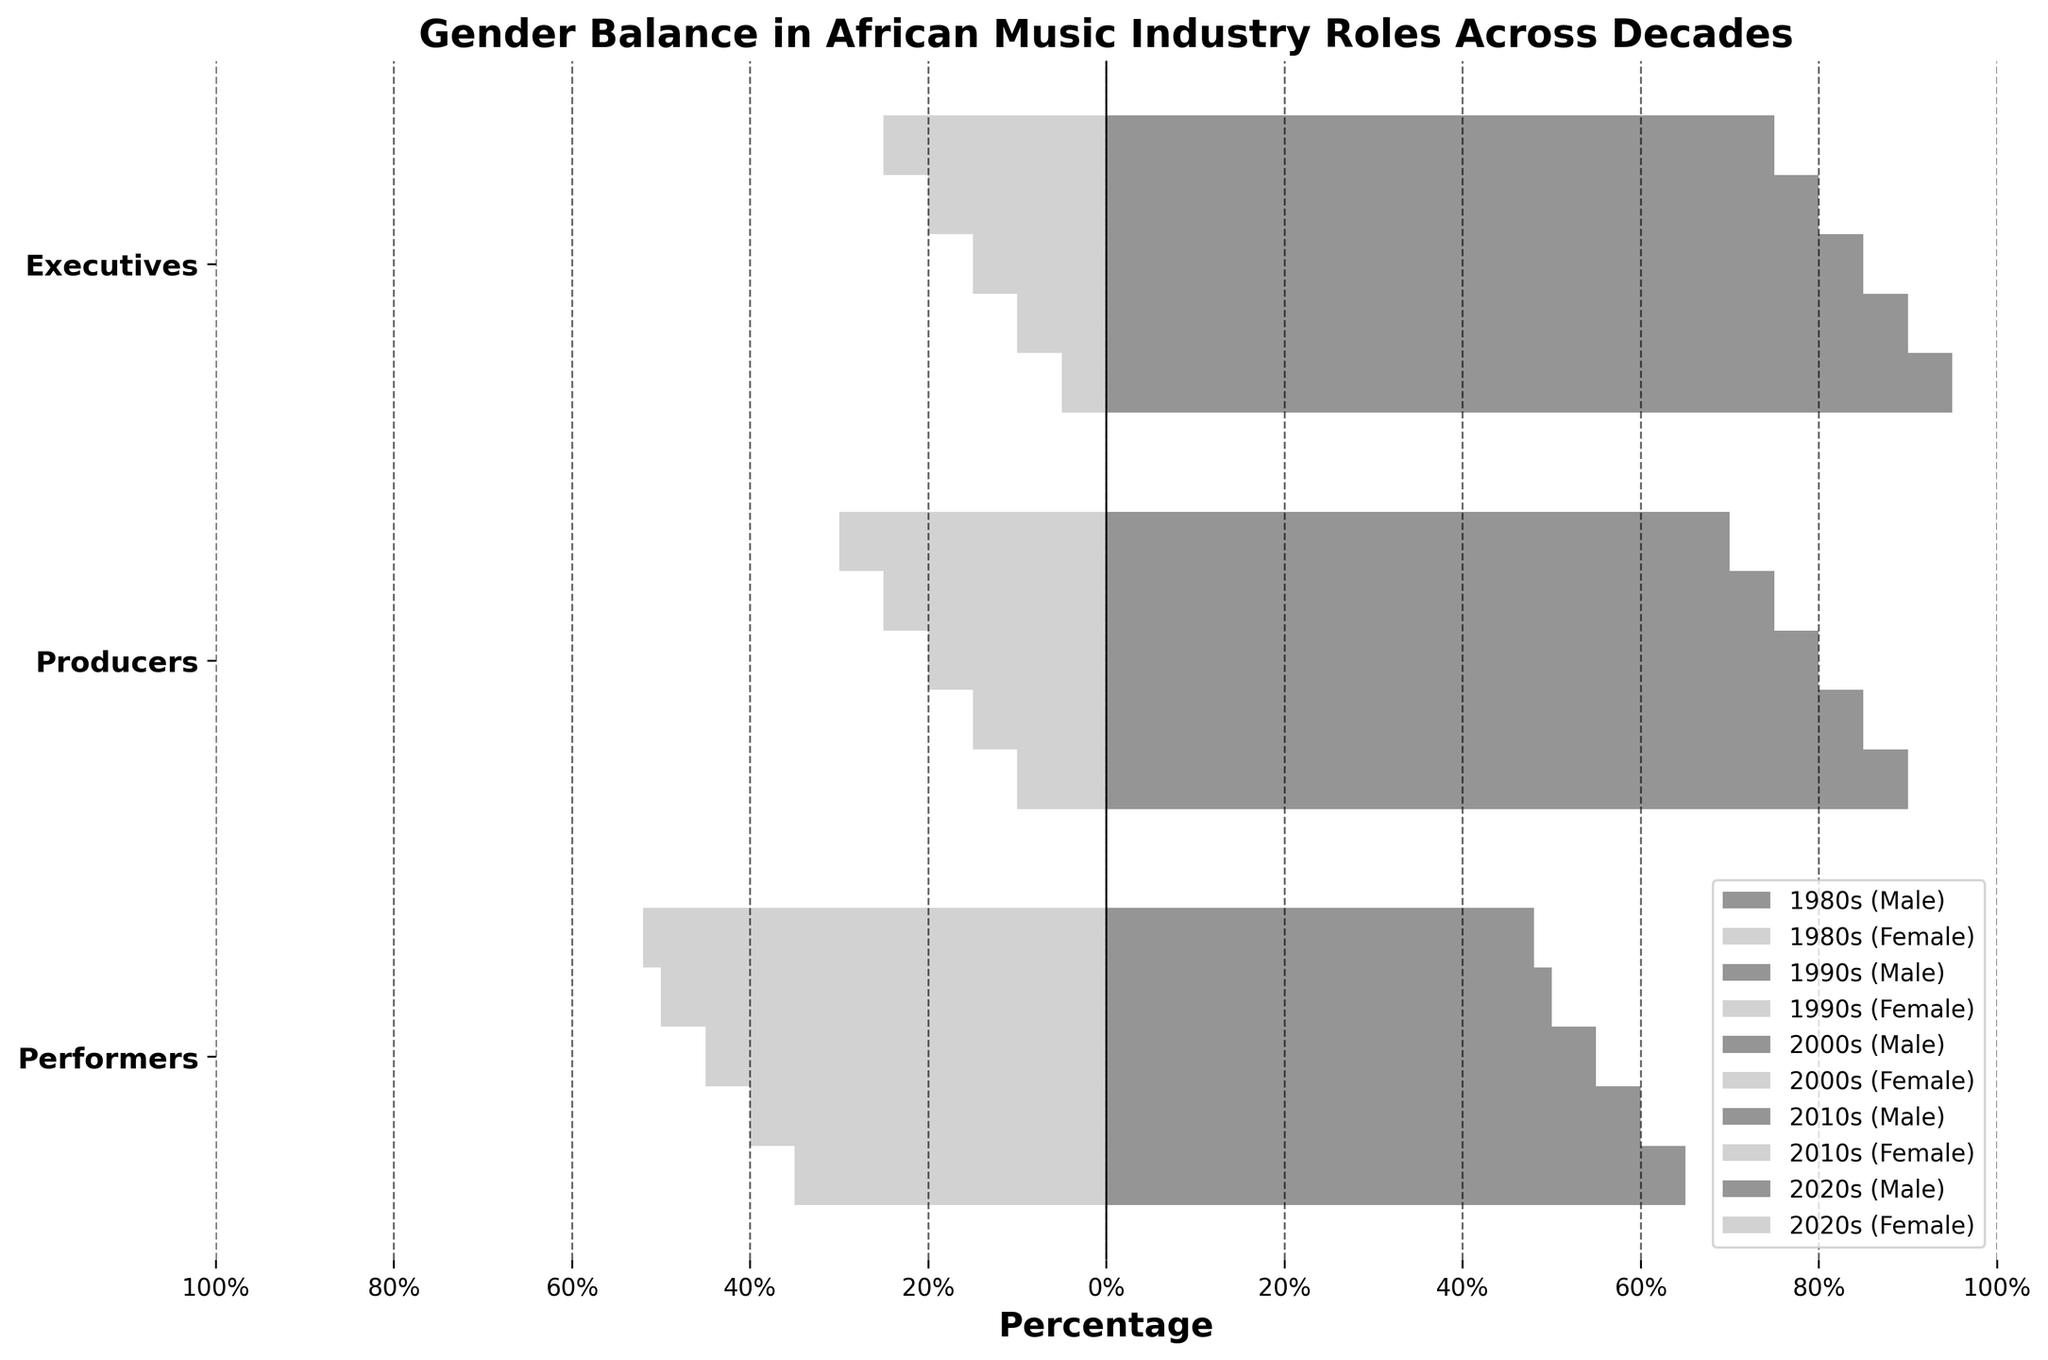What is the title of the plot? The title of the plot is located at the top of the figure. It reads "Gender Balance in African Music Industry Roles Across Decades".
Answer: Gender Balance in African Music Industry Roles Across Decades Which decade has the highest percentage of female performers? We need to look at the bars representing female performers for each decade. The 2020s have the highest female percentage at 52%.
Answer: 2020s What is the role with the smallest gender gap in the 2010s? By comparing the lengths of the male and female bars in the 2010s for each role, performers have an equal percentage of males and females (50% each), indicating the smallest gender gap.
Answer: Performers In the 1990s, by how much does the percentage of male executives exceed the percentage of male performers? The male percentage for executives in the 1990s is 90% and for performers, it's 60%. The difference is calculated as 90 - 60 = 30%.
Answer: 30% Which role shows the most significant improvement in gender balance between the 1980s and the 2020s? By comparing male and female percentages across roles and decades, we see that performers went from 35% female in the 1980s to 52% female in the 2020s, showing the most significant improvement.
Answer: Performers What is the trend for the percentage of male producers from 1980s to 2020s? Observing the male producers' percentages from each decade, we see it decreases progressively: 1980s (90%), 1990s (85%), 2000s (80%), 2010s (75%), 2020s (70%).
Answer: Decreasing How does the percentage of female executives in the 2000s compare to that in the 1980s? The figure shows female executives at 15% in the 2000s and 5% in the 1980s. The 2000s show an increase of (15 - 5)% = 10%.
Answer: 10% higher in the 2000s Across the decades, which role has the least variation in gender balance? Examining all roles across the decades, executives show the least variation: 90-95% male and 5-10% female.
Answer: Executives 